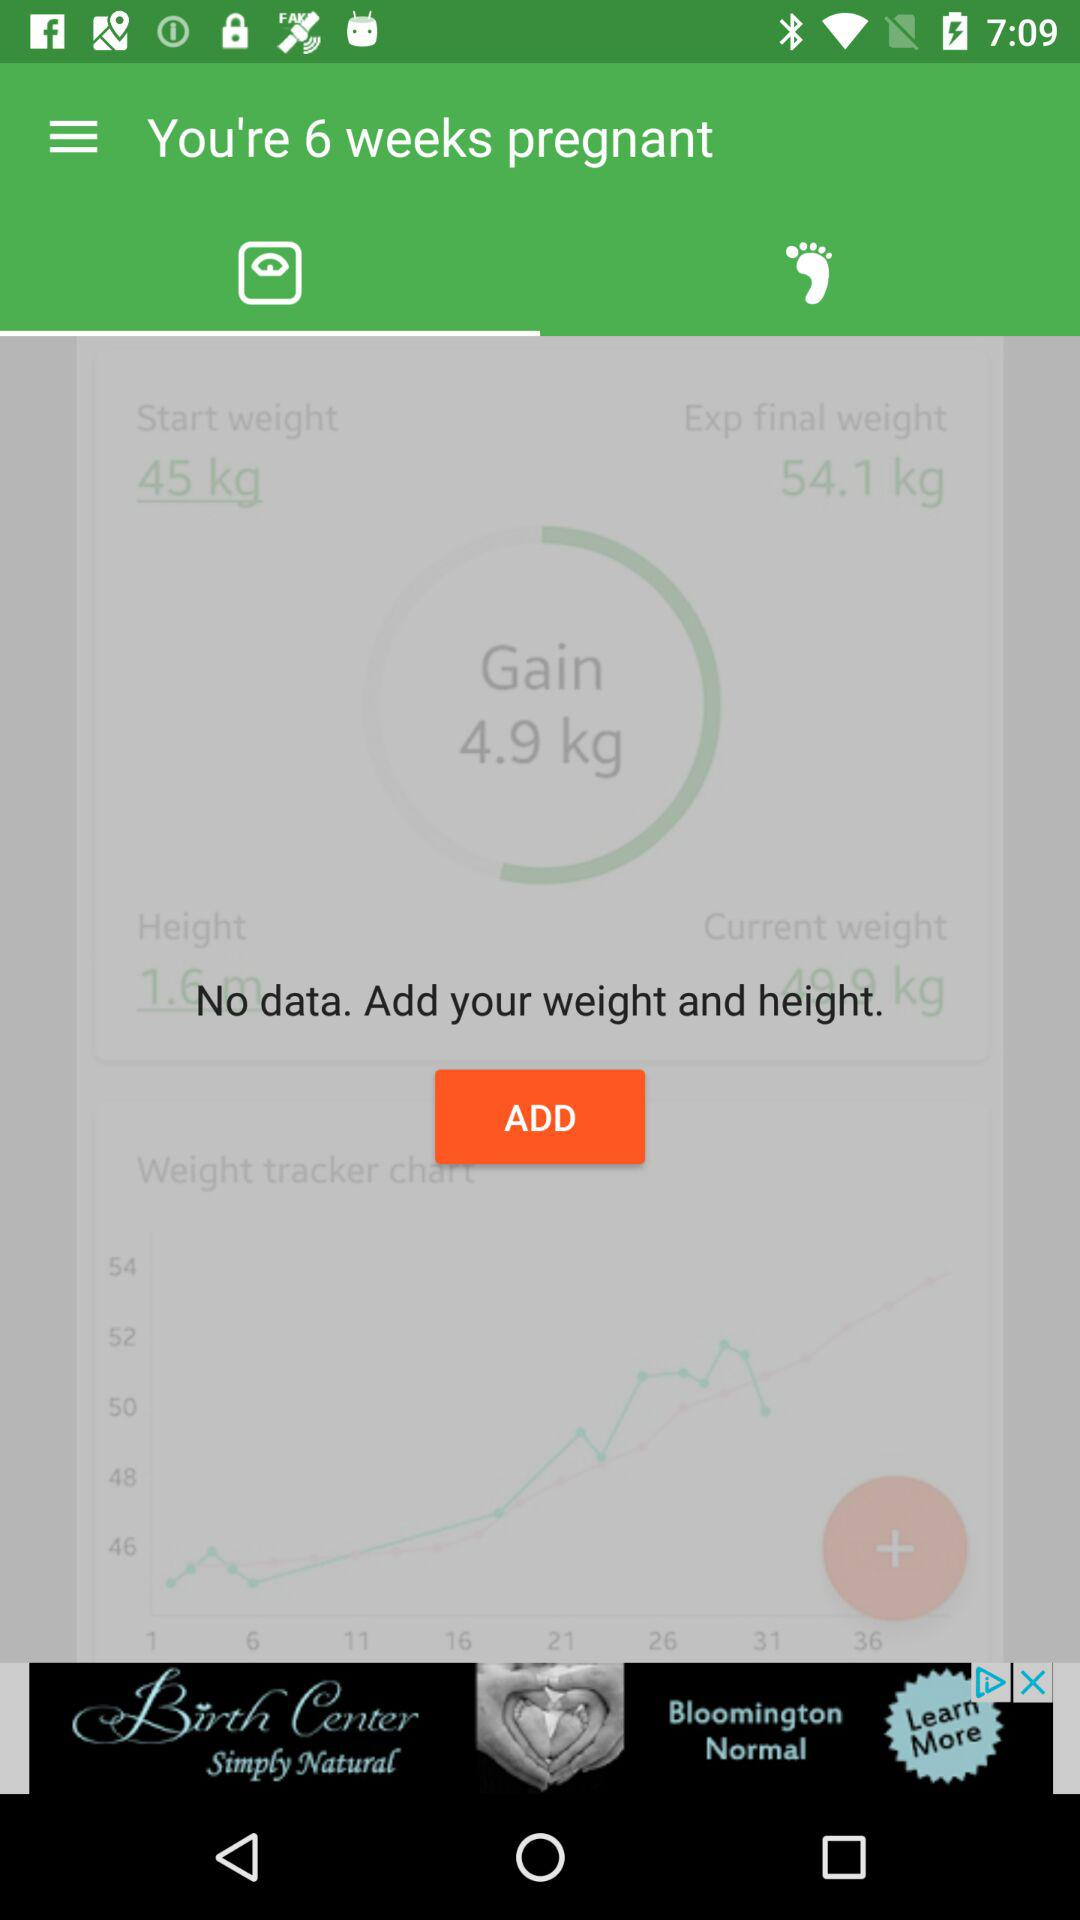How much more weight does the user expect to gain?
Answer the question using a single word or phrase. 4.9 kg 